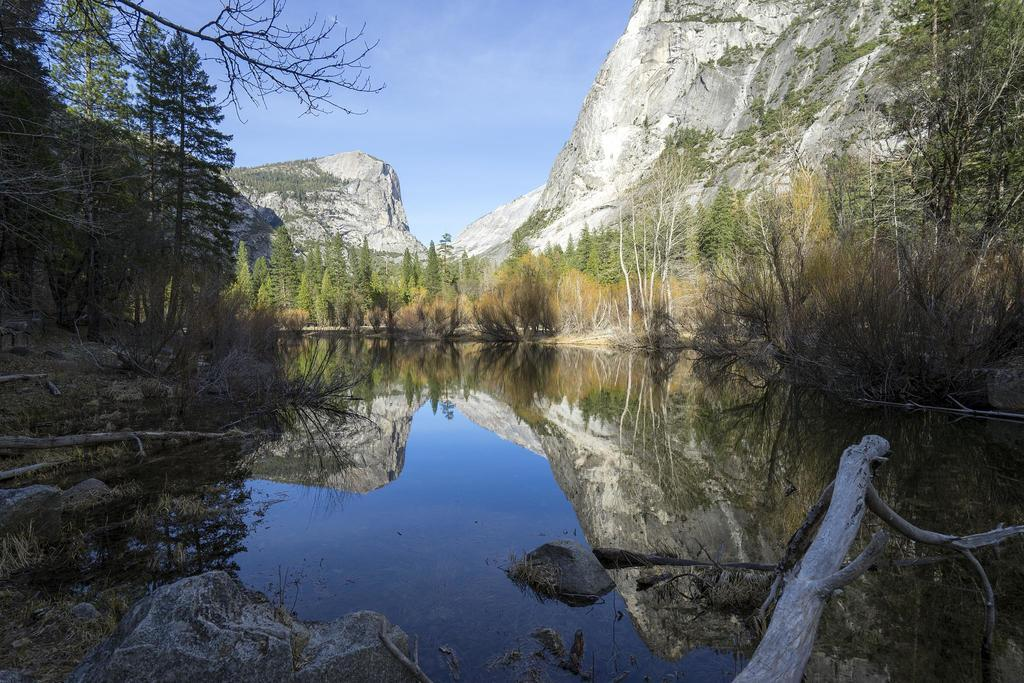What is the primary element in the image? There is water in the image. What can be seen near the water? There are trees beside the water. What other objects are present in the image? There are rocks in the image. What is visible in the background of the image? The sky is visible in the background of the image. How many bags of rice can be seen in the image? There is no rice present in the image. What type of trucks are visible in the image? There are no trucks present in the image. 